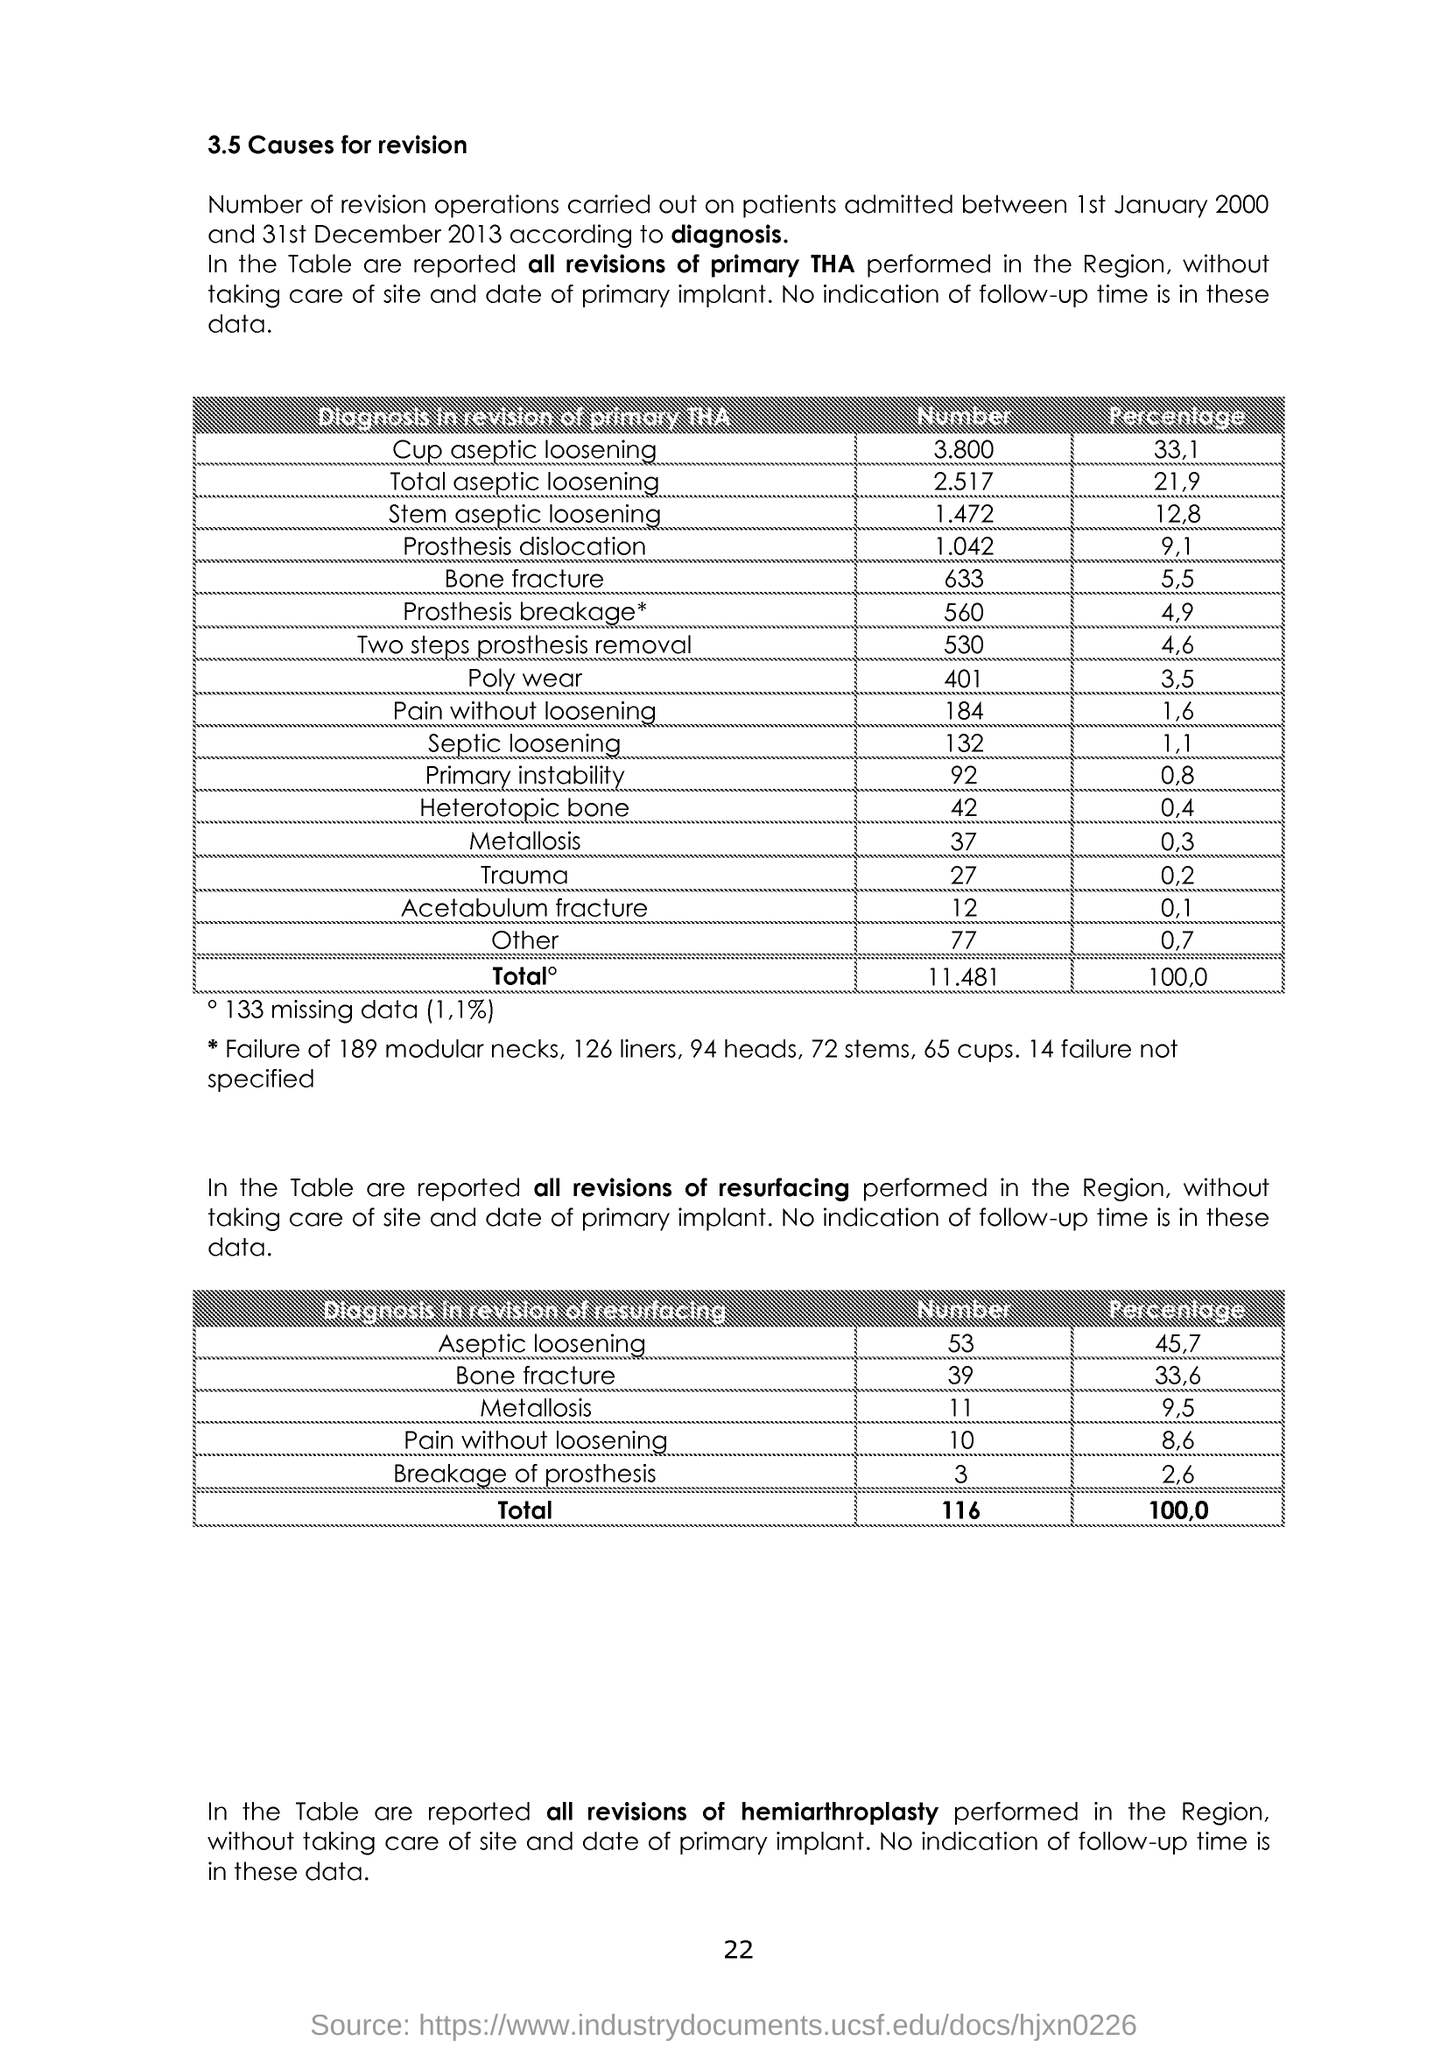Point out several critical features in this image. The number of Poly wear is 401. The percentage of trauma is 0.2. 